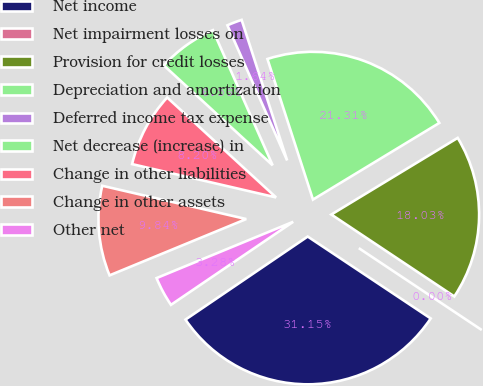<chart> <loc_0><loc_0><loc_500><loc_500><pie_chart><fcel>Net income<fcel>Net impairment losses on<fcel>Provision for credit losses<fcel>Depreciation and amortization<fcel>Deferred income tax expense<fcel>Net decrease (increase) in<fcel>Change in other liabilities<fcel>Change in other assets<fcel>Other net<nl><fcel>31.15%<fcel>0.0%<fcel>18.03%<fcel>21.31%<fcel>1.64%<fcel>6.56%<fcel>8.2%<fcel>9.84%<fcel>3.28%<nl></chart> 